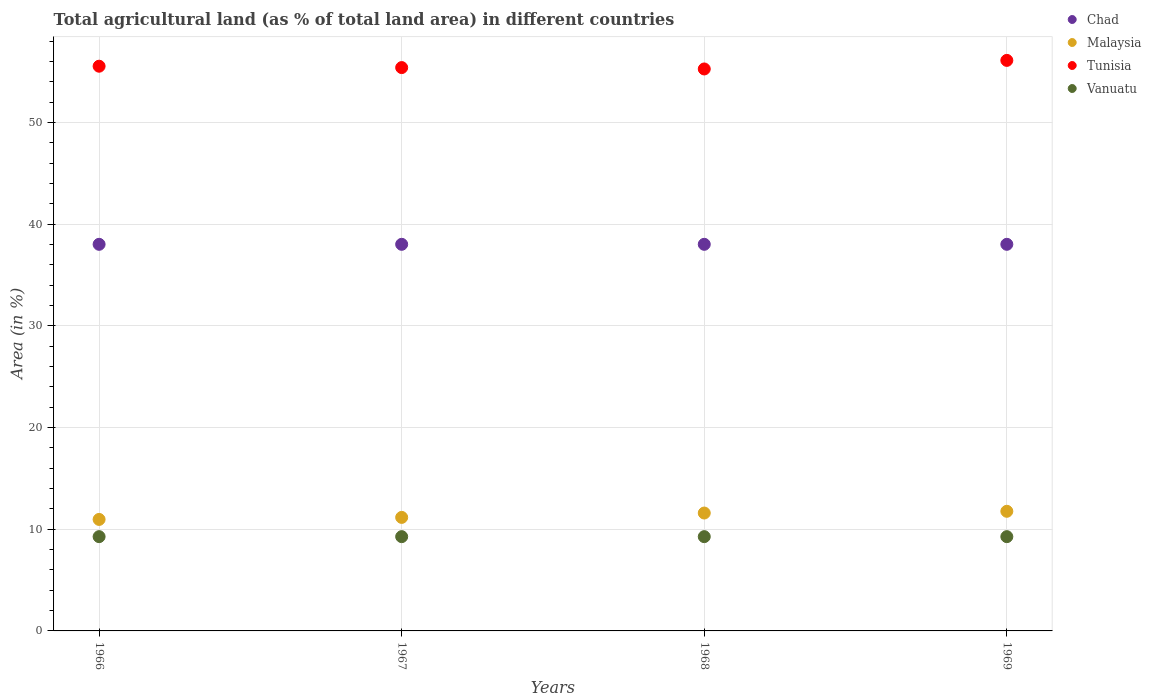Is the number of dotlines equal to the number of legend labels?
Ensure brevity in your answer.  Yes. What is the percentage of agricultural land in Tunisia in 1967?
Provide a succinct answer. 55.39. Across all years, what is the maximum percentage of agricultural land in Vanuatu?
Your answer should be compact. 9.27. Across all years, what is the minimum percentage of agricultural land in Malaysia?
Offer a terse response. 10.96. In which year was the percentage of agricultural land in Chad maximum?
Provide a short and direct response. 1966. In which year was the percentage of agricultural land in Tunisia minimum?
Provide a short and direct response. 1968. What is the total percentage of agricultural land in Chad in the graph?
Offer a terse response. 152.06. What is the difference between the percentage of agricultural land in Chad in 1966 and that in 1969?
Offer a terse response. 0. What is the difference between the percentage of agricultural land in Vanuatu in 1966 and the percentage of agricultural land in Tunisia in 1968?
Ensure brevity in your answer.  -45.99. What is the average percentage of agricultural land in Vanuatu per year?
Your answer should be compact. 9.27. In the year 1967, what is the difference between the percentage of agricultural land in Vanuatu and percentage of agricultural land in Malaysia?
Make the answer very short. -1.89. In how many years, is the percentage of agricultural land in Tunisia greater than 30 %?
Provide a short and direct response. 4. What is the ratio of the percentage of agricultural land in Tunisia in 1967 to that in 1969?
Keep it short and to the point. 0.99. Is the percentage of agricultural land in Malaysia in 1968 less than that in 1969?
Your answer should be compact. Yes. Is the difference between the percentage of agricultural land in Vanuatu in 1966 and 1968 greater than the difference between the percentage of agricultural land in Malaysia in 1966 and 1968?
Provide a succinct answer. Yes. What is the difference between the highest and the lowest percentage of agricultural land in Tunisia?
Keep it short and to the point. 0.84. Is the sum of the percentage of agricultural land in Chad in 1967 and 1969 greater than the maximum percentage of agricultural land in Tunisia across all years?
Offer a terse response. Yes. Is the percentage of agricultural land in Vanuatu strictly less than the percentage of agricultural land in Tunisia over the years?
Provide a short and direct response. Yes. How many dotlines are there?
Ensure brevity in your answer.  4. How many years are there in the graph?
Keep it short and to the point. 4. What is the difference between two consecutive major ticks on the Y-axis?
Offer a very short reply. 10. Does the graph contain grids?
Provide a succinct answer. Yes. What is the title of the graph?
Your response must be concise. Total agricultural land (as % of total land area) in different countries. Does "Egypt, Arab Rep." appear as one of the legend labels in the graph?
Make the answer very short. No. What is the label or title of the Y-axis?
Your response must be concise. Area (in %). What is the Area (in %) of Chad in 1966?
Make the answer very short. 38.02. What is the Area (in %) of Malaysia in 1966?
Offer a very short reply. 10.96. What is the Area (in %) in Tunisia in 1966?
Make the answer very short. 55.53. What is the Area (in %) in Vanuatu in 1966?
Your response must be concise. 9.27. What is the Area (in %) in Chad in 1967?
Provide a short and direct response. 38.02. What is the Area (in %) of Malaysia in 1967?
Your answer should be compact. 11.16. What is the Area (in %) in Tunisia in 1967?
Offer a very short reply. 55.39. What is the Area (in %) in Vanuatu in 1967?
Offer a very short reply. 9.27. What is the Area (in %) in Chad in 1968?
Offer a terse response. 38.02. What is the Area (in %) of Malaysia in 1968?
Give a very brief answer. 11.59. What is the Area (in %) in Tunisia in 1968?
Offer a terse response. 55.26. What is the Area (in %) in Vanuatu in 1968?
Your answer should be compact. 9.27. What is the Area (in %) in Chad in 1969?
Your answer should be compact. 38.02. What is the Area (in %) in Malaysia in 1969?
Give a very brief answer. 11.76. What is the Area (in %) of Tunisia in 1969?
Give a very brief answer. 56.1. What is the Area (in %) of Vanuatu in 1969?
Your answer should be very brief. 9.27. Across all years, what is the maximum Area (in %) in Chad?
Offer a very short reply. 38.02. Across all years, what is the maximum Area (in %) of Malaysia?
Keep it short and to the point. 11.76. Across all years, what is the maximum Area (in %) of Tunisia?
Ensure brevity in your answer.  56.1. Across all years, what is the maximum Area (in %) of Vanuatu?
Keep it short and to the point. 9.27. Across all years, what is the minimum Area (in %) of Chad?
Provide a short and direct response. 38.02. Across all years, what is the minimum Area (in %) of Malaysia?
Make the answer very short. 10.96. Across all years, what is the minimum Area (in %) of Tunisia?
Offer a terse response. 55.26. Across all years, what is the minimum Area (in %) in Vanuatu?
Your answer should be compact. 9.27. What is the total Area (in %) in Chad in the graph?
Make the answer very short. 152.06. What is the total Area (in %) in Malaysia in the graph?
Make the answer very short. 45.48. What is the total Area (in %) in Tunisia in the graph?
Give a very brief answer. 222.28. What is the total Area (in %) in Vanuatu in the graph?
Ensure brevity in your answer.  37.08. What is the difference between the Area (in %) of Malaysia in 1966 and that in 1967?
Your answer should be very brief. -0.2. What is the difference between the Area (in %) in Tunisia in 1966 and that in 1967?
Make the answer very short. 0.14. What is the difference between the Area (in %) in Malaysia in 1966 and that in 1968?
Keep it short and to the point. -0.63. What is the difference between the Area (in %) in Tunisia in 1966 and that in 1968?
Your response must be concise. 0.27. What is the difference between the Area (in %) in Vanuatu in 1966 and that in 1968?
Make the answer very short. 0. What is the difference between the Area (in %) of Malaysia in 1966 and that in 1969?
Offer a terse response. -0.8. What is the difference between the Area (in %) of Tunisia in 1966 and that in 1969?
Your answer should be very brief. -0.57. What is the difference between the Area (in %) in Vanuatu in 1966 and that in 1969?
Keep it short and to the point. 0. What is the difference between the Area (in %) in Malaysia in 1967 and that in 1968?
Make the answer very short. -0.43. What is the difference between the Area (in %) in Tunisia in 1967 and that in 1968?
Ensure brevity in your answer.  0.14. What is the difference between the Area (in %) of Vanuatu in 1967 and that in 1968?
Give a very brief answer. 0. What is the difference between the Area (in %) in Chad in 1967 and that in 1969?
Ensure brevity in your answer.  0. What is the difference between the Area (in %) in Malaysia in 1967 and that in 1969?
Keep it short and to the point. -0.6. What is the difference between the Area (in %) in Tunisia in 1967 and that in 1969?
Give a very brief answer. -0.71. What is the difference between the Area (in %) in Malaysia in 1968 and that in 1969?
Your answer should be compact. -0.17. What is the difference between the Area (in %) in Tunisia in 1968 and that in 1969?
Ensure brevity in your answer.  -0.84. What is the difference between the Area (in %) of Vanuatu in 1968 and that in 1969?
Give a very brief answer. 0. What is the difference between the Area (in %) of Chad in 1966 and the Area (in %) of Malaysia in 1967?
Provide a short and direct response. 26.85. What is the difference between the Area (in %) of Chad in 1966 and the Area (in %) of Tunisia in 1967?
Ensure brevity in your answer.  -17.38. What is the difference between the Area (in %) in Chad in 1966 and the Area (in %) in Vanuatu in 1967?
Offer a terse response. 28.75. What is the difference between the Area (in %) in Malaysia in 1966 and the Area (in %) in Tunisia in 1967?
Offer a very short reply. -44.43. What is the difference between the Area (in %) in Malaysia in 1966 and the Area (in %) in Vanuatu in 1967?
Your answer should be compact. 1.69. What is the difference between the Area (in %) of Tunisia in 1966 and the Area (in %) of Vanuatu in 1967?
Offer a very short reply. 46.26. What is the difference between the Area (in %) of Chad in 1966 and the Area (in %) of Malaysia in 1968?
Ensure brevity in your answer.  26.42. What is the difference between the Area (in %) of Chad in 1966 and the Area (in %) of Tunisia in 1968?
Give a very brief answer. -17.24. What is the difference between the Area (in %) in Chad in 1966 and the Area (in %) in Vanuatu in 1968?
Offer a very short reply. 28.75. What is the difference between the Area (in %) in Malaysia in 1966 and the Area (in %) in Tunisia in 1968?
Your answer should be very brief. -44.3. What is the difference between the Area (in %) of Malaysia in 1966 and the Area (in %) of Vanuatu in 1968?
Offer a very short reply. 1.69. What is the difference between the Area (in %) of Tunisia in 1966 and the Area (in %) of Vanuatu in 1968?
Provide a short and direct response. 46.26. What is the difference between the Area (in %) in Chad in 1966 and the Area (in %) in Malaysia in 1969?
Provide a short and direct response. 26.25. What is the difference between the Area (in %) of Chad in 1966 and the Area (in %) of Tunisia in 1969?
Provide a short and direct response. -18.09. What is the difference between the Area (in %) of Chad in 1966 and the Area (in %) of Vanuatu in 1969?
Ensure brevity in your answer.  28.75. What is the difference between the Area (in %) in Malaysia in 1966 and the Area (in %) in Tunisia in 1969?
Your answer should be very brief. -45.14. What is the difference between the Area (in %) of Malaysia in 1966 and the Area (in %) of Vanuatu in 1969?
Provide a succinct answer. 1.69. What is the difference between the Area (in %) in Tunisia in 1966 and the Area (in %) in Vanuatu in 1969?
Your answer should be very brief. 46.26. What is the difference between the Area (in %) in Chad in 1967 and the Area (in %) in Malaysia in 1968?
Offer a very short reply. 26.42. What is the difference between the Area (in %) in Chad in 1967 and the Area (in %) in Tunisia in 1968?
Provide a succinct answer. -17.24. What is the difference between the Area (in %) of Chad in 1967 and the Area (in %) of Vanuatu in 1968?
Provide a short and direct response. 28.75. What is the difference between the Area (in %) of Malaysia in 1967 and the Area (in %) of Tunisia in 1968?
Offer a very short reply. -44.1. What is the difference between the Area (in %) of Malaysia in 1967 and the Area (in %) of Vanuatu in 1968?
Provide a succinct answer. 1.89. What is the difference between the Area (in %) of Tunisia in 1967 and the Area (in %) of Vanuatu in 1968?
Offer a very short reply. 46.12. What is the difference between the Area (in %) of Chad in 1967 and the Area (in %) of Malaysia in 1969?
Provide a short and direct response. 26.25. What is the difference between the Area (in %) of Chad in 1967 and the Area (in %) of Tunisia in 1969?
Offer a very short reply. -18.09. What is the difference between the Area (in %) in Chad in 1967 and the Area (in %) in Vanuatu in 1969?
Ensure brevity in your answer.  28.75. What is the difference between the Area (in %) in Malaysia in 1967 and the Area (in %) in Tunisia in 1969?
Make the answer very short. -44.94. What is the difference between the Area (in %) of Malaysia in 1967 and the Area (in %) of Vanuatu in 1969?
Provide a succinct answer. 1.89. What is the difference between the Area (in %) in Tunisia in 1967 and the Area (in %) in Vanuatu in 1969?
Provide a short and direct response. 46.12. What is the difference between the Area (in %) in Chad in 1968 and the Area (in %) in Malaysia in 1969?
Provide a succinct answer. 26.25. What is the difference between the Area (in %) in Chad in 1968 and the Area (in %) in Tunisia in 1969?
Your answer should be compact. -18.09. What is the difference between the Area (in %) of Chad in 1968 and the Area (in %) of Vanuatu in 1969?
Your answer should be very brief. 28.75. What is the difference between the Area (in %) of Malaysia in 1968 and the Area (in %) of Tunisia in 1969?
Your answer should be compact. -44.51. What is the difference between the Area (in %) of Malaysia in 1968 and the Area (in %) of Vanuatu in 1969?
Offer a terse response. 2.32. What is the difference between the Area (in %) of Tunisia in 1968 and the Area (in %) of Vanuatu in 1969?
Your answer should be very brief. 45.99. What is the average Area (in %) of Chad per year?
Make the answer very short. 38.02. What is the average Area (in %) in Malaysia per year?
Provide a short and direct response. 11.37. What is the average Area (in %) of Tunisia per year?
Offer a terse response. 55.57. What is the average Area (in %) of Vanuatu per year?
Your answer should be compact. 9.27. In the year 1966, what is the difference between the Area (in %) of Chad and Area (in %) of Malaysia?
Ensure brevity in your answer.  27.05. In the year 1966, what is the difference between the Area (in %) of Chad and Area (in %) of Tunisia?
Your answer should be very brief. -17.51. In the year 1966, what is the difference between the Area (in %) in Chad and Area (in %) in Vanuatu?
Ensure brevity in your answer.  28.75. In the year 1966, what is the difference between the Area (in %) of Malaysia and Area (in %) of Tunisia?
Your answer should be compact. -44.57. In the year 1966, what is the difference between the Area (in %) in Malaysia and Area (in %) in Vanuatu?
Provide a short and direct response. 1.69. In the year 1966, what is the difference between the Area (in %) in Tunisia and Area (in %) in Vanuatu?
Your answer should be very brief. 46.26. In the year 1967, what is the difference between the Area (in %) in Chad and Area (in %) in Malaysia?
Provide a succinct answer. 26.85. In the year 1967, what is the difference between the Area (in %) in Chad and Area (in %) in Tunisia?
Offer a terse response. -17.38. In the year 1967, what is the difference between the Area (in %) of Chad and Area (in %) of Vanuatu?
Your response must be concise. 28.75. In the year 1967, what is the difference between the Area (in %) of Malaysia and Area (in %) of Tunisia?
Offer a terse response. -44.23. In the year 1967, what is the difference between the Area (in %) of Malaysia and Area (in %) of Vanuatu?
Your answer should be compact. 1.89. In the year 1967, what is the difference between the Area (in %) of Tunisia and Area (in %) of Vanuatu?
Your answer should be compact. 46.12. In the year 1968, what is the difference between the Area (in %) in Chad and Area (in %) in Malaysia?
Offer a very short reply. 26.42. In the year 1968, what is the difference between the Area (in %) in Chad and Area (in %) in Tunisia?
Make the answer very short. -17.24. In the year 1968, what is the difference between the Area (in %) in Chad and Area (in %) in Vanuatu?
Your answer should be compact. 28.75. In the year 1968, what is the difference between the Area (in %) of Malaysia and Area (in %) of Tunisia?
Your answer should be very brief. -43.67. In the year 1968, what is the difference between the Area (in %) in Malaysia and Area (in %) in Vanuatu?
Keep it short and to the point. 2.32. In the year 1968, what is the difference between the Area (in %) of Tunisia and Area (in %) of Vanuatu?
Provide a short and direct response. 45.99. In the year 1969, what is the difference between the Area (in %) in Chad and Area (in %) in Malaysia?
Keep it short and to the point. 26.25. In the year 1969, what is the difference between the Area (in %) in Chad and Area (in %) in Tunisia?
Provide a short and direct response. -18.09. In the year 1969, what is the difference between the Area (in %) in Chad and Area (in %) in Vanuatu?
Keep it short and to the point. 28.75. In the year 1969, what is the difference between the Area (in %) in Malaysia and Area (in %) in Tunisia?
Give a very brief answer. -44.34. In the year 1969, what is the difference between the Area (in %) of Malaysia and Area (in %) of Vanuatu?
Give a very brief answer. 2.49. In the year 1969, what is the difference between the Area (in %) in Tunisia and Area (in %) in Vanuatu?
Keep it short and to the point. 46.83. What is the ratio of the Area (in %) of Malaysia in 1966 to that in 1967?
Make the answer very short. 0.98. What is the ratio of the Area (in %) in Vanuatu in 1966 to that in 1967?
Offer a very short reply. 1. What is the ratio of the Area (in %) of Chad in 1966 to that in 1968?
Make the answer very short. 1. What is the ratio of the Area (in %) in Malaysia in 1966 to that in 1968?
Provide a succinct answer. 0.95. What is the ratio of the Area (in %) of Tunisia in 1966 to that in 1968?
Ensure brevity in your answer.  1. What is the ratio of the Area (in %) of Chad in 1966 to that in 1969?
Offer a terse response. 1. What is the ratio of the Area (in %) of Malaysia in 1966 to that in 1969?
Keep it short and to the point. 0.93. What is the ratio of the Area (in %) in Tunisia in 1966 to that in 1969?
Provide a succinct answer. 0.99. What is the ratio of the Area (in %) of Vanuatu in 1966 to that in 1969?
Keep it short and to the point. 1. What is the ratio of the Area (in %) of Chad in 1967 to that in 1968?
Keep it short and to the point. 1. What is the ratio of the Area (in %) of Malaysia in 1967 to that in 1968?
Provide a succinct answer. 0.96. What is the ratio of the Area (in %) of Tunisia in 1967 to that in 1968?
Your answer should be very brief. 1. What is the ratio of the Area (in %) in Malaysia in 1967 to that in 1969?
Provide a succinct answer. 0.95. What is the ratio of the Area (in %) of Tunisia in 1967 to that in 1969?
Your answer should be compact. 0.99. What is the ratio of the Area (in %) in Malaysia in 1968 to that in 1969?
Ensure brevity in your answer.  0.99. What is the ratio of the Area (in %) in Vanuatu in 1968 to that in 1969?
Ensure brevity in your answer.  1. What is the difference between the highest and the second highest Area (in %) in Malaysia?
Make the answer very short. 0.17. What is the difference between the highest and the second highest Area (in %) in Tunisia?
Give a very brief answer. 0.57. What is the difference between the highest and the second highest Area (in %) of Vanuatu?
Keep it short and to the point. 0. What is the difference between the highest and the lowest Area (in %) of Chad?
Give a very brief answer. 0. What is the difference between the highest and the lowest Area (in %) in Malaysia?
Offer a very short reply. 0.8. What is the difference between the highest and the lowest Area (in %) in Tunisia?
Keep it short and to the point. 0.84. 